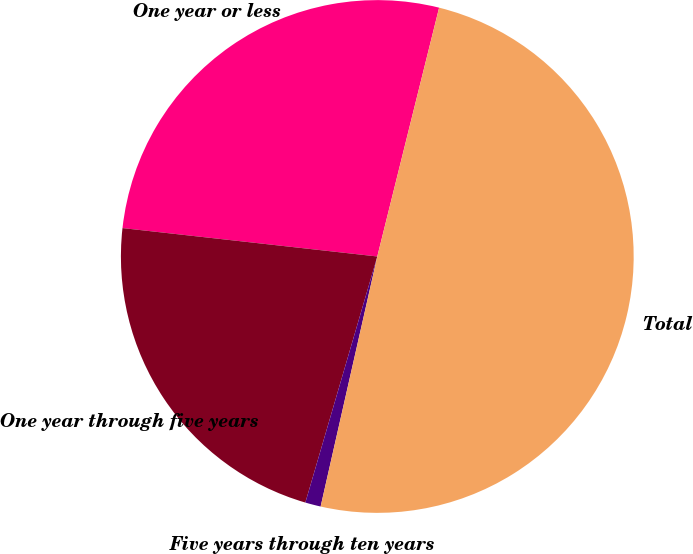<chart> <loc_0><loc_0><loc_500><loc_500><pie_chart><fcel>One year or less<fcel>One year through five years<fcel>Five years through ten years<fcel>Total<nl><fcel>27.11%<fcel>22.24%<fcel>0.98%<fcel>49.67%<nl></chart> 